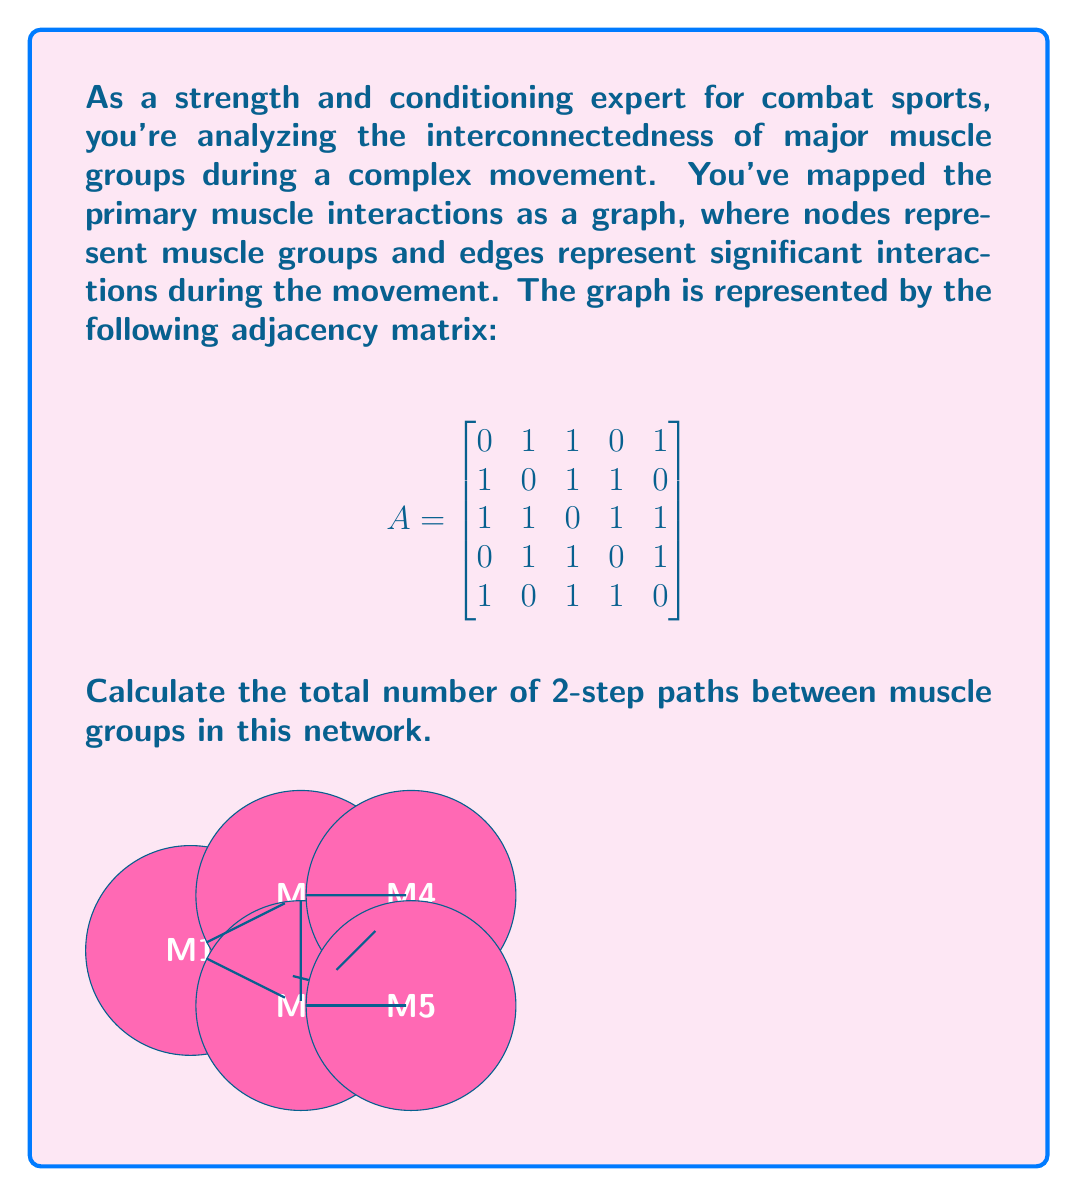Can you solve this math problem? Let's approach this step-by-step:

1) In graph theory, the number of 2-step paths between nodes in a graph can be calculated using the square of the adjacency matrix. Let's call this matrix $A^2$.

2) The formula for $A^2$ is:

   $$(A^2)_{ij} = \sum_{k=1}^n A_{ik}A_{kj}$$

   where $n$ is the number of nodes (in this case, 5).

3) We can calculate $A^2$ by multiplying $A$ by itself:

   $$
   A^2 = \begin{bmatrix}
   0 & 1 & 1 & 0 & 1 \\
   1 & 0 & 1 & 1 & 0 \\
   1 & 1 & 0 & 1 & 1 \\
   0 & 1 & 1 & 0 & 1 \\
   1 & 0 & 1 & 1 & 0
   \end{bmatrix} \times 
   \begin{bmatrix}
   0 & 1 & 1 & 0 & 1 \\
   1 & 0 & 1 & 1 & 0 \\
   1 & 1 & 0 & 1 & 1 \\
   0 & 1 & 1 & 0 & 1 \\
   1 & 0 & 1 & 1 & 0
   \end{bmatrix}
   $$

4) After multiplication, we get:

   $$
   A^2 = \begin{bmatrix}
   3 & 1 & 2 & 3 & 1 \\
   1 & 3 & 2 & 1 & 3 \\
   2 & 2 & 4 & 2 & 2 \\
   3 & 1 & 2 & 3 & 1 \\
   1 & 3 & 2 & 1 & 3
   \end{bmatrix}
   $$

5) The entry $(A^2)_{ij}$ gives the number of 2-step paths from node $i$ to node $j$.

6) To find the total number of 2-step paths, we sum all entries in $A^2$:

   $$3 + 1 + 2 + 3 + 1 + 1 + 3 + 2 + 1 + 3 + 2 + 2 + 4 + 2 + 2 + 3 + 1 + 2 + 3 + 1 + 1 + 3 + 2 + 1 + 3 = 48$$

Therefore, there are 48 2-step paths in total between muscle groups in this network.
Answer: 48 